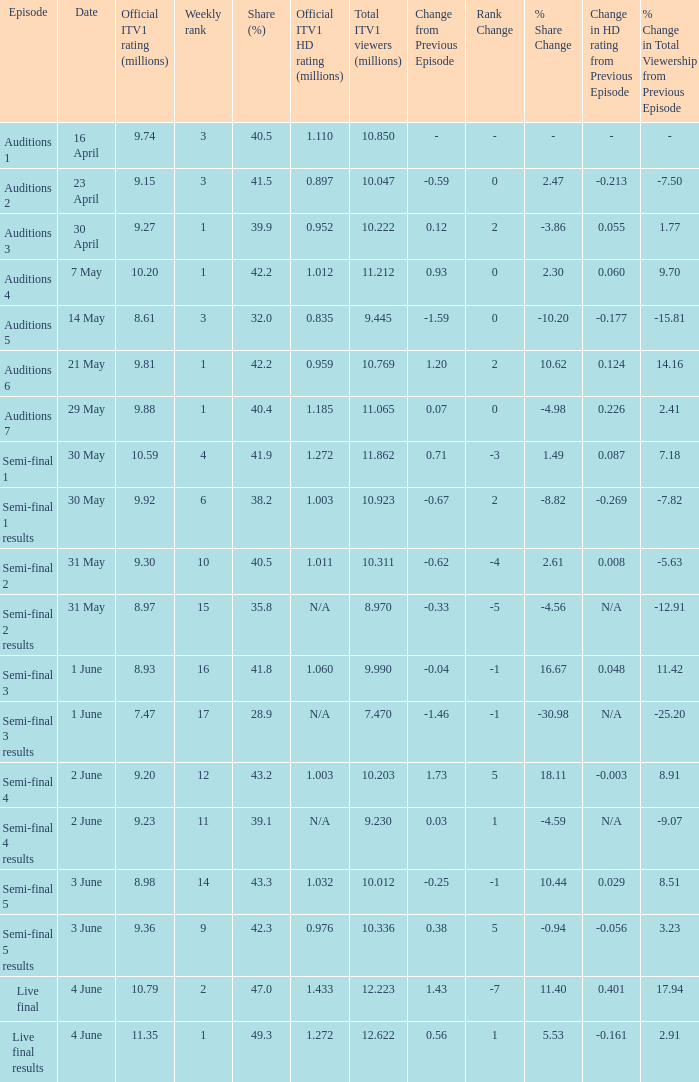5% share? 23 April. 